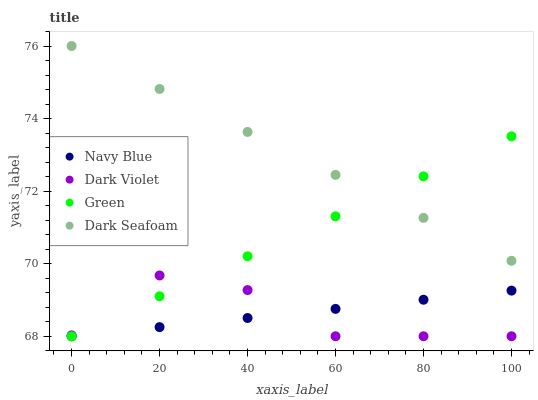Does Dark Violet have the minimum area under the curve?
Answer yes or no. Yes. Does Dark Seafoam have the maximum area under the curve?
Answer yes or no. Yes. Does Green have the minimum area under the curve?
Answer yes or no. No. Does Green have the maximum area under the curve?
Answer yes or no. No. Is Navy Blue the smoothest?
Answer yes or no. Yes. Is Dark Violet the roughest?
Answer yes or no. Yes. Is Dark Seafoam the smoothest?
Answer yes or no. No. Is Dark Seafoam the roughest?
Answer yes or no. No. Does Navy Blue have the lowest value?
Answer yes or no. Yes. Does Dark Seafoam have the lowest value?
Answer yes or no. No. Does Dark Seafoam have the highest value?
Answer yes or no. Yes. Does Green have the highest value?
Answer yes or no. No. Is Navy Blue less than Dark Seafoam?
Answer yes or no. Yes. Is Dark Seafoam greater than Dark Violet?
Answer yes or no. Yes. Does Green intersect Navy Blue?
Answer yes or no. Yes. Is Green less than Navy Blue?
Answer yes or no. No. Is Green greater than Navy Blue?
Answer yes or no. No. Does Navy Blue intersect Dark Seafoam?
Answer yes or no. No. 